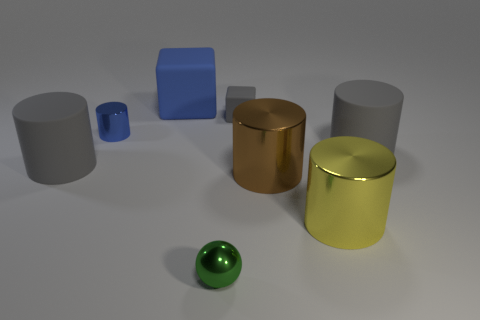Subtract all blue cylinders. How many cylinders are left? 4 Subtract all brown metallic cylinders. How many cylinders are left? 4 Subtract all red cylinders. Subtract all cyan balls. How many cylinders are left? 5 Add 2 tiny gray matte things. How many objects exist? 10 Subtract all spheres. How many objects are left? 7 Subtract all large brown metal cylinders. Subtract all big matte cylinders. How many objects are left? 5 Add 4 small cylinders. How many small cylinders are left? 5 Add 4 big brown cylinders. How many big brown cylinders exist? 5 Subtract 1 blue blocks. How many objects are left? 7 